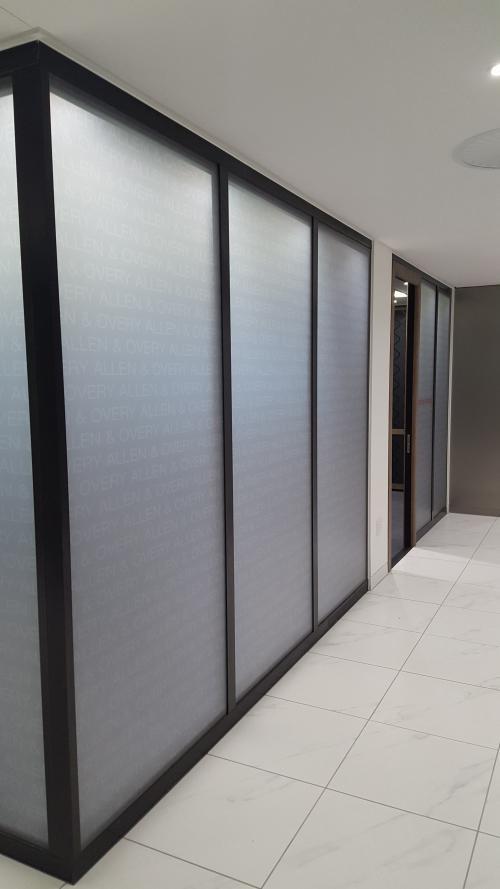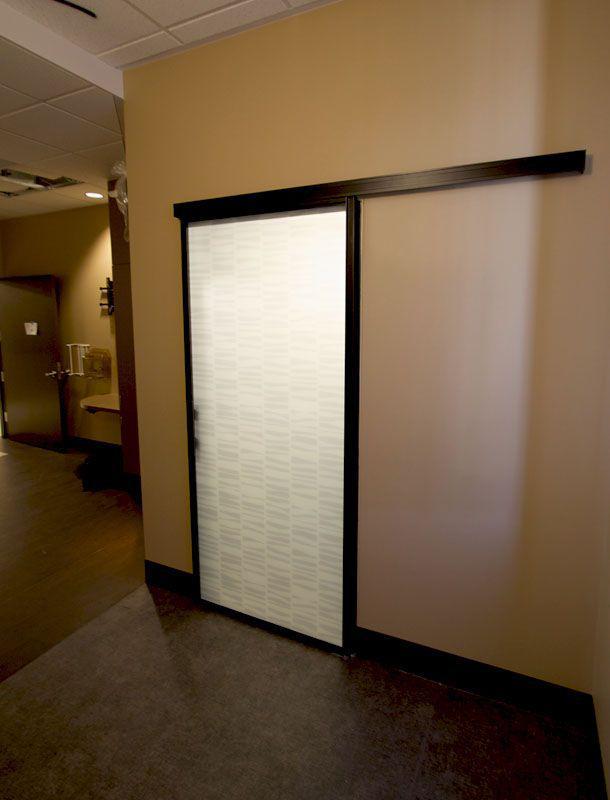The first image is the image on the left, the second image is the image on the right. Analyze the images presented: Is the assertion "In at least one image there is a sliver elevator and the other image is ofwhite frame glass windows." valid? Answer yes or no. No. The first image is the image on the left, the second image is the image on the right. Evaluate the accuracy of this statement regarding the images: "One image features silver elevator doors, and the other image features glass windows that reach nearly to the ceiling.". Is it true? Answer yes or no. No. 